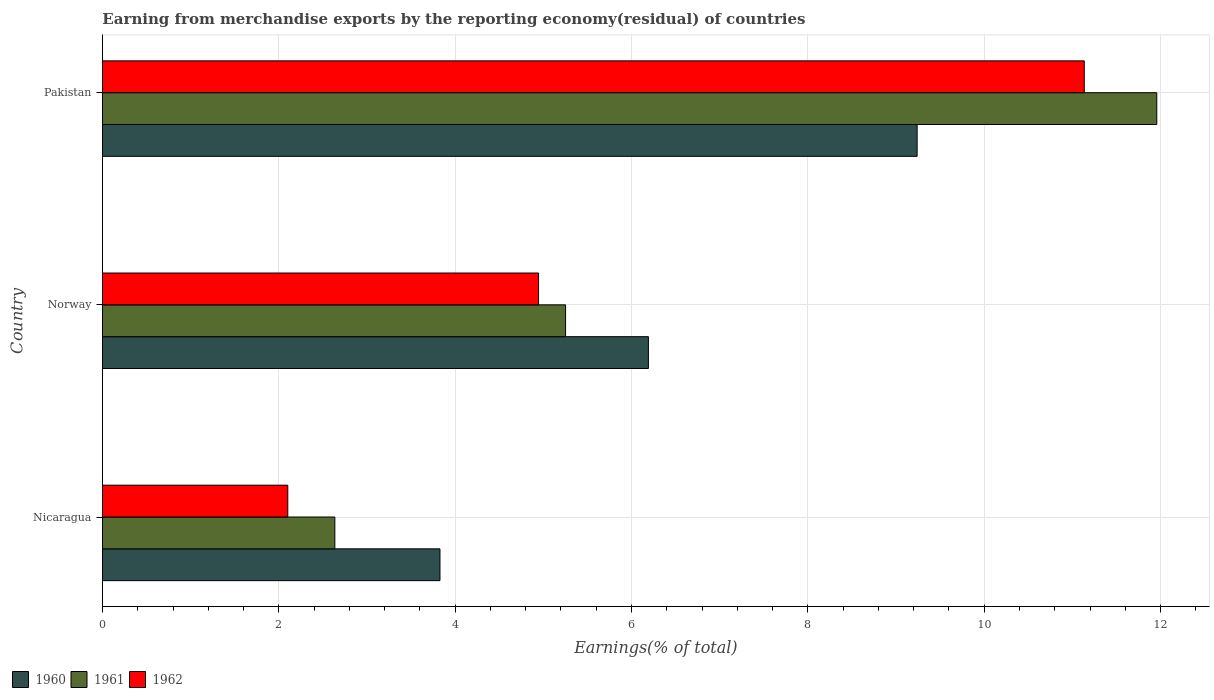How many groups of bars are there?
Give a very brief answer. 3. Are the number of bars per tick equal to the number of legend labels?
Make the answer very short. Yes. How many bars are there on the 2nd tick from the top?
Provide a short and direct response. 3. What is the label of the 3rd group of bars from the top?
Provide a short and direct response. Nicaragua. In how many cases, is the number of bars for a given country not equal to the number of legend labels?
Give a very brief answer. 0. What is the percentage of amount earned from merchandise exports in 1960 in Nicaragua?
Your answer should be compact. 3.83. Across all countries, what is the maximum percentage of amount earned from merchandise exports in 1961?
Make the answer very short. 11.96. Across all countries, what is the minimum percentage of amount earned from merchandise exports in 1962?
Keep it short and to the point. 2.1. In which country was the percentage of amount earned from merchandise exports in 1962 minimum?
Keep it short and to the point. Nicaragua. What is the total percentage of amount earned from merchandise exports in 1961 in the graph?
Give a very brief answer. 19.85. What is the difference between the percentage of amount earned from merchandise exports in 1960 in Nicaragua and that in Norway?
Keep it short and to the point. -2.36. What is the difference between the percentage of amount earned from merchandise exports in 1962 in Nicaragua and the percentage of amount earned from merchandise exports in 1960 in Pakistan?
Your response must be concise. -7.14. What is the average percentage of amount earned from merchandise exports in 1962 per country?
Provide a short and direct response. 6.06. What is the difference between the percentage of amount earned from merchandise exports in 1962 and percentage of amount earned from merchandise exports in 1961 in Pakistan?
Offer a terse response. -0.82. What is the ratio of the percentage of amount earned from merchandise exports in 1960 in Norway to that in Pakistan?
Offer a very short reply. 0.67. Is the difference between the percentage of amount earned from merchandise exports in 1962 in Norway and Pakistan greater than the difference between the percentage of amount earned from merchandise exports in 1961 in Norway and Pakistan?
Offer a very short reply. Yes. What is the difference between the highest and the second highest percentage of amount earned from merchandise exports in 1961?
Offer a terse response. 6.7. What is the difference between the highest and the lowest percentage of amount earned from merchandise exports in 1961?
Give a very brief answer. 9.32. In how many countries, is the percentage of amount earned from merchandise exports in 1962 greater than the average percentage of amount earned from merchandise exports in 1962 taken over all countries?
Keep it short and to the point. 1. What does the 2nd bar from the bottom in Nicaragua represents?
Your answer should be compact. 1961. Is it the case that in every country, the sum of the percentage of amount earned from merchandise exports in 1962 and percentage of amount earned from merchandise exports in 1960 is greater than the percentage of amount earned from merchandise exports in 1961?
Ensure brevity in your answer.  Yes. How many bars are there?
Your answer should be compact. 9. How many countries are there in the graph?
Offer a terse response. 3. What is the difference between two consecutive major ticks on the X-axis?
Provide a short and direct response. 2. Are the values on the major ticks of X-axis written in scientific E-notation?
Your answer should be very brief. No. Does the graph contain any zero values?
Provide a succinct answer. No. How many legend labels are there?
Make the answer very short. 3. How are the legend labels stacked?
Ensure brevity in your answer.  Horizontal. What is the title of the graph?
Make the answer very short. Earning from merchandise exports by the reporting economy(residual) of countries. What is the label or title of the X-axis?
Offer a terse response. Earnings(% of total). What is the label or title of the Y-axis?
Offer a terse response. Country. What is the Earnings(% of total) in 1960 in Nicaragua?
Your response must be concise. 3.83. What is the Earnings(% of total) of 1961 in Nicaragua?
Offer a terse response. 2.64. What is the Earnings(% of total) in 1962 in Nicaragua?
Your answer should be very brief. 2.1. What is the Earnings(% of total) in 1960 in Norway?
Provide a short and direct response. 6.19. What is the Earnings(% of total) of 1961 in Norway?
Ensure brevity in your answer.  5.25. What is the Earnings(% of total) in 1962 in Norway?
Give a very brief answer. 4.95. What is the Earnings(% of total) in 1960 in Pakistan?
Keep it short and to the point. 9.24. What is the Earnings(% of total) in 1961 in Pakistan?
Your answer should be compact. 11.96. What is the Earnings(% of total) of 1962 in Pakistan?
Offer a very short reply. 11.14. Across all countries, what is the maximum Earnings(% of total) in 1960?
Provide a succinct answer. 9.24. Across all countries, what is the maximum Earnings(% of total) in 1961?
Provide a succinct answer. 11.96. Across all countries, what is the maximum Earnings(% of total) of 1962?
Your response must be concise. 11.14. Across all countries, what is the minimum Earnings(% of total) in 1960?
Keep it short and to the point. 3.83. Across all countries, what is the minimum Earnings(% of total) of 1961?
Give a very brief answer. 2.64. Across all countries, what is the minimum Earnings(% of total) of 1962?
Your response must be concise. 2.1. What is the total Earnings(% of total) in 1960 in the graph?
Ensure brevity in your answer.  19.26. What is the total Earnings(% of total) of 1961 in the graph?
Ensure brevity in your answer.  19.85. What is the total Earnings(% of total) in 1962 in the graph?
Give a very brief answer. 18.18. What is the difference between the Earnings(% of total) in 1960 in Nicaragua and that in Norway?
Offer a very short reply. -2.36. What is the difference between the Earnings(% of total) in 1961 in Nicaragua and that in Norway?
Provide a succinct answer. -2.62. What is the difference between the Earnings(% of total) in 1962 in Nicaragua and that in Norway?
Your answer should be very brief. -2.84. What is the difference between the Earnings(% of total) in 1960 in Nicaragua and that in Pakistan?
Your answer should be compact. -5.41. What is the difference between the Earnings(% of total) of 1961 in Nicaragua and that in Pakistan?
Offer a very short reply. -9.32. What is the difference between the Earnings(% of total) of 1962 in Nicaragua and that in Pakistan?
Your response must be concise. -9.03. What is the difference between the Earnings(% of total) of 1960 in Norway and that in Pakistan?
Offer a terse response. -3.05. What is the difference between the Earnings(% of total) in 1961 in Norway and that in Pakistan?
Offer a very short reply. -6.71. What is the difference between the Earnings(% of total) in 1962 in Norway and that in Pakistan?
Provide a short and direct response. -6.19. What is the difference between the Earnings(% of total) in 1960 in Nicaragua and the Earnings(% of total) in 1961 in Norway?
Your answer should be very brief. -1.42. What is the difference between the Earnings(% of total) of 1960 in Nicaragua and the Earnings(% of total) of 1962 in Norway?
Make the answer very short. -1.12. What is the difference between the Earnings(% of total) in 1961 in Nicaragua and the Earnings(% of total) in 1962 in Norway?
Your answer should be compact. -2.31. What is the difference between the Earnings(% of total) of 1960 in Nicaragua and the Earnings(% of total) of 1961 in Pakistan?
Keep it short and to the point. -8.13. What is the difference between the Earnings(% of total) of 1960 in Nicaragua and the Earnings(% of total) of 1962 in Pakistan?
Provide a succinct answer. -7.31. What is the difference between the Earnings(% of total) in 1961 in Nicaragua and the Earnings(% of total) in 1962 in Pakistan?
Your answer should be very brief. -8.5. What is the difference between the Earnings(% of total) in 1960 in Norway and the Earnings(% of total) in 1961 in Pakistan?
Keep it short and to the point. -5.77. What is the difference between the Earnings(% of total) of 1960 in Norway and the Earnings(% of total) of 1962 in Pakistan?
Offer a terse response. -4.94. What is the difference between the Earnings(% of total) of 1961 in Norway and the Earnings(% of total) of 1962 in Pakistan?
Offer a very short reply. -5.88. What is the average Earnings(% of total) in 1960 per country?
Your answer should be very brief. 6.42. What is the average Earnings(% of total) in 1961 per country?
Keep it short and to the point. 6.62. What is the average Earnings(% of total) of 1962 per country?
Offer a terse response. 6.06. What is the difference between the Earnings(% of total) in 1960 and Earnings(% of total) in 1961 in Nicaragua?
Offer a very short reply. 1.19. What is the difference between the Earnings(% of total) in 1960 and Earnings(% of total) in 1962 in Nicaragua?
Give a very brief answer. 1.73. What is the difference between the Earnings(% of total) of 1961 and Earnings(% of total) of 1962 in Nicaragua?
Provide a short and direct response. 0.53. What is the difference between the Earnings(% of total) of 1960 and Earnings(% of total) of 1961 in Norway?
Your answer should be compact. 0.94. What is the difference between the Earnings(% of total) of 1960 and Earnings(% of total) of 1962 in Norway?
Ensure brevity in your answer.  1.25. What is the difference between the Earnings(% of total) in 1961 and Earnings(% of total) in 1962 in Norway?
Ensure brevity in your answer.  0.31. What is the difference between the Earnings(% of total) in 1960 and Earnings(% of total) in 1961 in Pakistan?
Ensure brevity in your answer.  -2.72. What is the difference between the Earnings(% of total) of 1960 and Earnings(% of total) of 1962 in Pakistan?
Your answer should be very brief. -1.9. What is the difference between the Earnings(% of total) in 1961 and Earnings(% of total) in 1962 in Pakistan?
Your answer should be compact. 0.82. What is the ratio of the Earnings(% of total) in 1960 in Nicaragua to that in Norway?
Make the answer very short. 0.62. What is the ratio of the Earnings(% of total) in 1961 in Nicaragua to that in Norway?
Offer a terse response. 0.5. What is the ratio of the Earnings(% of total) of 1962 in Nicaragua to that in Norway?
Offer a very short reply. 0.42. What is the ratio of the Earnings(% of total) of 1960 in Nicaragua to that in Pakistan?
Your response must be concise. 0.41. What is the ratio of the Earnings(% of total) of 1961 in Nicaragua to that in Pakistan?
Provide a short and direct response. 0.22. What is the ratio of the Earnings(% of total) in 1962 in Nicaragua to that in Pakistan?
Ensure brevity in your answer.  0.19. What is the ratio of the Earnings(% of total) of 1960 in Norway to that in Pakistan?
Provide a short and direct response. 0.67. What is the ratio of the Earnings(% of total) in 1961 in Norway to that in Pakistan?
Your answer should be compact. 0.44. What is the ratio of the Earnings(% of total) in 1962 in Norway to that in Pakistan?
Ensure brevity in your answer.  0.44. What is the difference between the highest and the second highest Earnings(% of total) of 1960?
Provide a short and direct response. 3.05. What is the difference between the highest and the second highest Earnings(% of total) of 1961?
Give a very brief answer. 6.71. What is the difference between the highest and the second highest Earnings(% of total) of 1962?
Keep it short and to the point. 6.19. What is the difference between the highest and the lowest Earnings(% of total) of 1960?
Provide a succinct answer. 5.41. What is the difference between the highest and the lowest Earnings(% of total) in 1961?
Offer a very short reply. 9.32. What is the difference between the highest and the lowest Earnings(% of total) of 1962?
Ensure brevity in your answer.  9.03. 